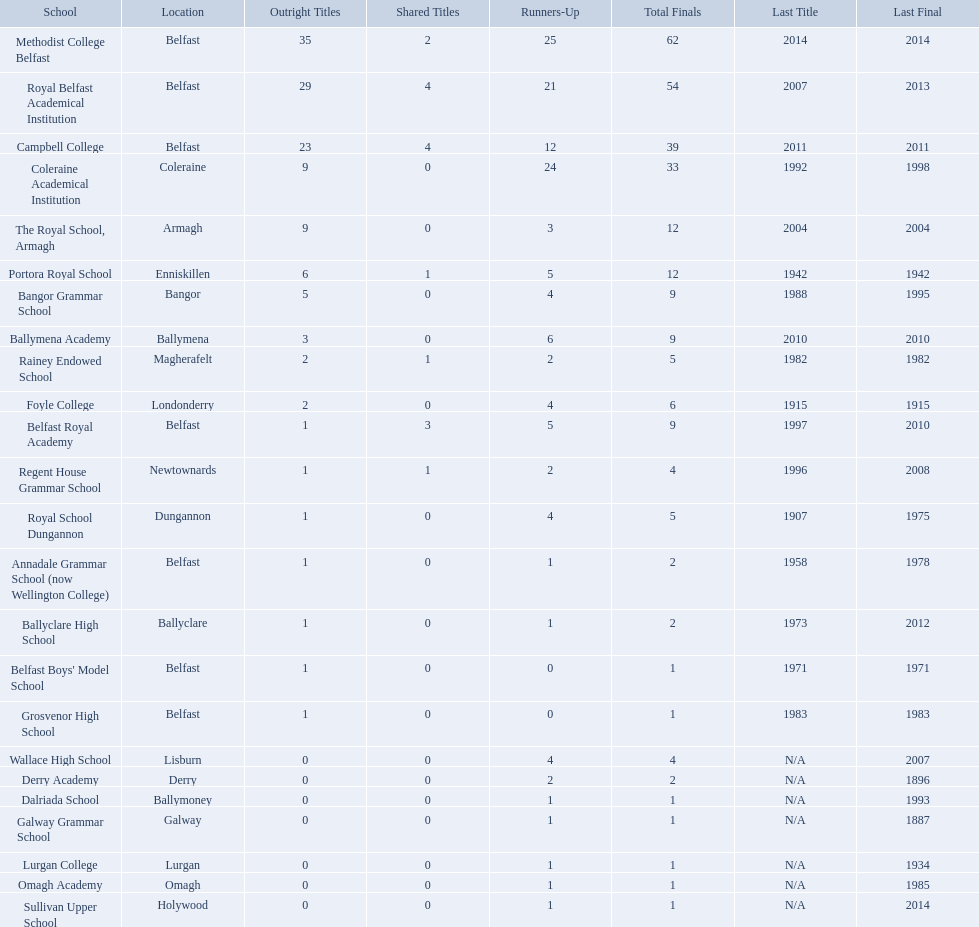How many outright titles does coleraine academical institution have? 9. What other school has this amount of outright titles The Royal School, Armagh. What were all of the school names? Methodist College Belfast, Royal Belfast Academical Institution, Campbell College, Coleraine Academical Institution, The Royal School, Armagh, Portora Royal School, Bangor Grammar School, Ballymena Academy, Rainey Endowed School, Foyle College, Belfast Royal Academy, Regent House Grammar School, Royal School Dungannon, Annadale Grammar School (now Wellington College), Ballyclare High School, Belfast Boys' Model School, Grosvenor High School, Wallace High School, Derry Academy, Dalriada School, Galway Grammar School, Lurgan College, Omagh Academy, Sullivan Upper School. How many outright titles did they achieve? 35, 29, 23, 9, 9, 6, 5, 3, 2, 2, 1, 1, 1, 1, 1, 1, 1, 0, 0, 0, 0, 0, 0, 0. And how many did coleraine academical institution receive? 9. Which other school had the same number of outright titles? The Royal School, Armagh. Write the full table. {'header': ['School', 'Location', 'Outright Titles', 'Shared Titles', 'Runners-Up', 'Total Finals', 'Last Title', 'Last Final'], 'rows': [['Methodist College Belfast', 'Belfast', '35', '2', '25', '62', '2014', '2014'], ['Royal Belfast Academical Institution', 'Belfast', '29', '4', '21', '54', '2007', '2013'], ['Campbell College', 'Belfast', '23', '4', '12', '39', '2011', '2011'], ['Coleraine Academical Institution', 'Coleraine', '9', '0', '24', '33', '1992', '1998'], ['The Royal School, Armagh', 'Armagh', '9', '0', '3', '12', '2004', '2004'], ['Portora Royal School', 'Enniskillen', '6', '1', '5', '12', '1942', '1942'], ['Bangor Grammar School', 'Bangor', '5', '0', '4', '9', '1988', '1995'], ['Ballymena Academy', 'Ballymena', '3', '0', '6', '9', '2010', '2010'], ['Rainey Endowed School', 'Magherafelt', '2', '1', '2', '5', '1982', '1982'], ['Foyle College', 'Londonderry', '2', '0', '4', '6', '1915', '1915'], ['Belfast Royal Academy', 'Belfast', '1', '3', '5', '9', '1997', '2010'], ['Regent House Grammar School', 'Newtownards', '1', '1', '2', '4', '1996', '2008'], ['Royal School Dungannon', 'Dungannon', '1', '0', '4', '5', '1907', '1975'], ['Annadale Grammar School (now Wellington College)', 'Belfast', '1', '0', '1', '2', '1958', '1978'], ['Ballyclare High School', 'Ballyclare', '1', '0', '1', '2', '1973', '2012'], ["Belfast Boys' Model School", 'Belfast', '1', '0', '0', '1', '1971', '1971'], ['Grosvenor High School', 'Belfast', '1', '0', '0', '1', '1983', '1983'], ['Wallace High School', 'Lisburn', '0', '0', '4', '4', 'N/A', '2007'], ['Derry Academy', 'Derry', '0', '0', '2', '2', 'N/A', '1896'], ['Dalriada School', 'Ballymoney', '0', '0', '1', '1', 'N/A', '1993'], ['Galway Grammar School', 'Galway', '0', '0', '1', '1', 'N/A', '1887'], ['Lurgan College', 'Lurgan', '0', '0', '1', '1', 'N/A', '1934'], ['Omagh Academy', 'Omagh', '0', '0', '1', '1', 'N/A', '1985'], ['Sullivan Upper School', 'Holywood', '0', '0', '1', '1', 'N/A', '2014']]} How many schools are there? Methodist College Belfast, Royal Belfast Academical Institution, Campbell College, Coleraine Academical Institution, The Royal School, Armagh, Portora Royal School, Bangor Grammar School, Ballymena Academy, Rainey Endowed School, Foyle College, Belfast Royal Academy, Regent House Grammar School, Royal School Dungannon, Annadale Grammar School (now Wellington College), Ballyclare High School, Belfast Boys' Model School, Grosvenor High School, Wallace High School, Derry Academy, Dalriada School, Galway Grammar School, Lurgan College, Omagh Academy, Sullivan Upper School. How many outright titles does the coleraine academical institution have? 9. What other school has the same number of outright titles? The Royal School, Armagh. Which schools are listed? Methodist College Belfast, Royal Belfast Academical Institution, Campbell College, Coleraine Academical Institution, The Royal School, Armagh, Portora Royal School, Bangor Grammar School, Ballymena Academy, Rainey Endowed School, Foyle College, Belfast Royal Academy, Regent House Grammar School, Royal School Dungannon, Annadale Grammar School (now Wellington College), Ballyclare High School, Belfast Boys' Model School, Grosvenor High School, Wallace High School, Derry Academy, Dalriada School, Galway Grammar School, Lurgan College, Omagh Academy, Sullivan Upper School. When did campbell college win the title last? 2011. When did regent house grammar school win the title last? 1996. Of those two who had the most recent title win? Campbell College. What schools are referred to? Methodist College Belfast, Royal Belfast Academical Institution, Campbell College, Coleraine Academical Institution, The Royal School, Armagh, Portora Royal School, Bangor Grammar School, Ballymena Academy, Rainey Endowed School, Foyle College, Belfast Royal Academy, Regent House Grammar School, Royal School Dungannon, Annadale Grammar School (now Wellington College), Ballyclare High School, Belfast Boys' Model School, Grosvenor High School, Wallace High School, Derry Academy, Dalriada School, Galway Grammar School, Lurgan College, Omagh Academy, Sullivan Upper School. When was campbell college's previous title win? 2011. When did regent house grammar school last obtain the championship? 1996. Out of those two, who had the most current title triumph? Campbell College. What were the various school names? Methodist College Belfast, Royal Belfast Academical Institution, Campbell College, Coleraine Academical Institution, The Royal School, Armagh, Portora Royal School, Bangor Grammar School, Ballymena Academy, Rainey Endowed School, Foyle College, Belfast Royal Academy, Regent House Grammar School, Royal School Dungannon, Annadale Grammar School (now Wellington College), Ballyclare High School, Belfast Boys' Model School, Grosvenor High School, Wallace High School, Derry Academy, Dalriada School, Galway Grammar School, Lurgan College, Omagh Academy, Sullivan Upper School. Can you give me this table as a dict? {'header': ['School', 'Location', 'Outright Titles', 'Shared Titles', 'Runners-Up', 'Total Finals', 'Last Title', 'Last Final'], 'rows': [['Methodist College Belfast', 'Belfast', '35', '2', '25', '62', '2014', '2014'], ['Royal Belfast Academical Institution', 'Belfast', '29', '4', '21', '54', '2007', '2013'], ['Campbell College', 'Belfast', '23', '4', '12', '39', '2011', '2011'], ['Coleraine Academical Institution', 'Coleraine', '9', '0', '24', '33', '1992', '1998'], ['The Royal School, Armagh', 'Armagh', '9', '0', '3', '12', '2004', '2004'], ['Portora Royal School', 'Enniskillen', '6', '1', '5', '12', '1942', '1942'], ['Bangor Grammar School', 'Bangor', '5', '0', '4', '9', '1988', '1995'], ['Ballymena Academy', 'Ballymena', '3', '0', '6', '9', '2010', '2010'], ['Rainey Endowed School', 'Magherafelt', '2', '1', '2', '5', '1982', '1982'], ['Foyle College', 'Londonderry', '2', '0', '4', '6', '1915', '1915'], ['Belfast Royal Academy', 'Belfast', '1', '3', '5', '9', '1997', '2010'], ['Regent House Grammar School', 'Newtownards', '1', '1', '2', '4', '1996', '2008'], ['Royal School Dungannon', 'Dungannon', '1', '0', '4', '5', '1907', '1975'], ['Annadale Grammar School (now Wellington College)', 'Belfast', '1', '0', '1', '2', '1958', '1978'], ['Ballyclare High School', 'Ballyclare', '1', '0', '1', '2', '1973', '2012'], ["Belfast Boys' Model School", 'Belfast', '1', '0', '0', '1', '1971', '1971'], ['Grosvenor High School', 'Belfast', '1', '0', '0', '1', '1983', '1983'], ['Wallace High School', 'Lisburn', '0', '0', '4', '4', 'N/A', '2007'], ['Derry Academy', 'Derry', '0', '0', '2', '2', 'N/A', '1896'], ['Dalriada School', 'Ballymoney', '0', '0', '1', '1', 'N/A', '1993'], ['Galway Grammar School', 'Galway', '0', '0', '1', '1', 'N/A', '1887'], ['Lurgan College', 'Lurgan', '0', '0', '1', '1', 'N/A', '1934'], ['Omagh Academy', 'Omagh', '0', '0', '1', '1', 'N/A', '1985'], ['Sullivan Upper School', 'Holywood', '0', '0', '1', '1', 'N/A', '2014']]} How many total titles did they achieve? 35, 29, 23, 9, 9, 6, 5, 3, 2, 2, 1, 1, 1, 1, 1, 1, 1, 0, 0, 0, 0, 0, 0, 0. And how many titles did coleraine academical institution obtain? 9. Which other school had an equal number of total titles? The Royal School, Armagh. What is the latest victory of campbell college? 2011. What is the latest victory of regent house grammar school? 1996. Which date is more current? 2011. What is the name of the school with this date? Campbell College. How many unshared championships does coleraine academical institution own? 9. Which other educational establishment has this volume of unshared championships? The Royal School, Armagh. What is the most recent success of campbell college? 2011. What is the most recent success of regent house grammar school? 1996. Which date is more recent? 2011. What is the name of the school with this date? Campbell College. Which educational institutions are mentioned? Methodist College Belfast, Royal Belfast Academical Institution, Campbell College, Coleraine Academical Institution, The Royal School, Armagh, Portora Royal School, Bangor Grammar School, Ballymena Academy, Rainey Endowed School, Foyle College, Belfast Royal Academy, Regent House Grammar School, Royal School Dungannon, Annadale Grammar School (now Wellington College), Ballyclare High School, Belfast Boys' Model School, Grosvenor High School, Wallace High School, Derry Academy, Dalriada School, Galway Grammar School, Lurgan College, Omagh Academy, Sullivan Upper School. When was the last time campbell college claimed the championship? 2011. When did regent house grammar school last secure the title? 1996. Among the two, who had the latest title victory? Campbell College. How many educational institutions exist? Methodist College Belfast, Royal Belfast Academical Institution, Campbell College, Coleraine Academical Institution, The Royal School, Armagh, Portora Royal School, Bangor Grammar School, Ballymena Academy, Rainey Endowed School, Foyle College, Belfast Royal Academy, Regent House Grammar School, Royal School Dungannon, Annadale Grammar School (now Wellington College), Ballyclare High School, Belfast Boys' Model School, Grosvenor High School, Wallace High School, Derry Academy, Dalriada School, Galway Grammar School, Lurgan College, Omagh Academy, Sullivan Upper School. How many undisputed championships does the coleraine academical institution hold? 9. Which other school possesses the same quantity of undisputed championships? The Royal School, Armagh. Which schools are named? Methodist College Belfast, Royal Belfast Academical Institution, Campbell College, Coleraine Academical Institution, The Royal School, Armagh, Portora Royal School, Bangor Grammar School, Ballymena Academy, Rainey Endowed School, Foyle College, Belfast Royal Academy, Regent House Grammar School, Royal School Dungannon, Annadale Grammar School (now Wellington College), Ballyclare High School, Belfast Boys' Model School, Grosvenor High School, Wallace High School, Derry Academy, Dalriada School, Galway Grammar School, Lurgan College, Omagh Academy, Sullivan Upper School. When did campbell college last achieve the title? 2011. When was regent house grammar school's most recent title win? 1996. Between the two, who won the championship most recently? Campbell College. What's the count of schools? Methodist College Belfast, Royal Belfast Academical Institution, Campbell College, Coleraine Academical Institution, The Royal School, Armagh, Portora Royal School, Bangor Grammar School, Ballymena Academy, Rainey Endowed School, Foyle College, Belfast Royal Academy, Regent House Grammar School, Royal School Dungannon, Annadale Grammar School (now Wellington College), Ballyclare High School, Belfast Boys' Model School, Grosvenor High School, Wallace High School, Derry Academy, Dalriada School, Galway Grammar School, Lurgan College, Omagh Academy, Sullivan Upper School. How many complete titles has the coleraine academical institution achieved? 9. Can you name another school with an identical count of complete titles? The Royal School, Armagh. What are the names of the schools mentioned? Methodist College Belfast, Royal Belfast Academical Institution, Campbell College, Coleraine Academical Institution, The Royal School, Armagh, Portora Royal School, Bangor Grammar School, Ballymena Academy, Rainey Endowed School, Foyle College, Belfast Royal Academy, Regent House Grammar School, Royal School Dungannon, Annadale Grammar School (now Wellington College), Ballyclare High School, Belfast Boys' Model School, Grosvenor High School, Wallace High School, Derry Academy, Dalriada School, Galway Grammar School, Lurgan College, Omagh Academy, Sullivan Upper School. When was campbell college's latest title victory? 2011. When was regent house grammar school's most recent title win? 1996. Between the two, who had the most recent championship win? Campbell College. Which educational institutions are mentioned? Methodist College Belfast, Royal Belfast Academical Institution, Campbell College, Coleraine Academical Institution, The Royal School, Armagh, Portora Royal School, Bangor Grammar School, Ballymena Academy, Rainey Endowed School, Foyle College, Belfast Royal Academy, Regent House Grammar School, Royal School Dungannon, Annadale Grammar School (now Wellington College), Ballyclare High School, Belfast Boys' Model School, Grosvenor High School, Wallace High School, Derry Academy, Dalriada School, Galway Grammar School, Lurgan College, Omagh Academy, Sullivan Upper School. When was the last time campbell college claimed the title? 2011. When did regent house grammar school last hold the title? 1996. Who among them had the latest title win? Campbell College. What schools are being discussed? Methodist College Belfast, Royal Belfast Academical Institution, Campbell College, Coleraine Academical Institution, The Royal School, Armagh, Portora Royal School, Bangor Grammar School, Ballymena Academy, Rainey Endowed School, Foyle College, Belfast Royal Academy, Regent House Grammar School, Royal School Dungannon, Annadale Grammar School (now Wellington College), Ballyclare High School, Belfast Boys' Model School, Grosvenor High School, Wallace High School, Derry Academy, Dalriada School, Galway Grammar School, Lurgan College, Omagh Academy, Sullivan Upper School. When did campbell college last secure the title? 2011. When was regent house grammar school's previous title-winning moment? 1996. Out of the two, who had a more recent title victory? Campbell College. What is the latest victory for campbell college? 2011. What is the latest victory for regent house grammar school? 1996. Which of these dates is more recent? 2011. Which school has this most recent date? Campbell College. What is the newest triumph of campbell college? 2011. What is the newest triumph of regent house grammar school? 1996. Which of these moments is the latest? 2011. What is the name of the educational institution with this date? Campbell College. 